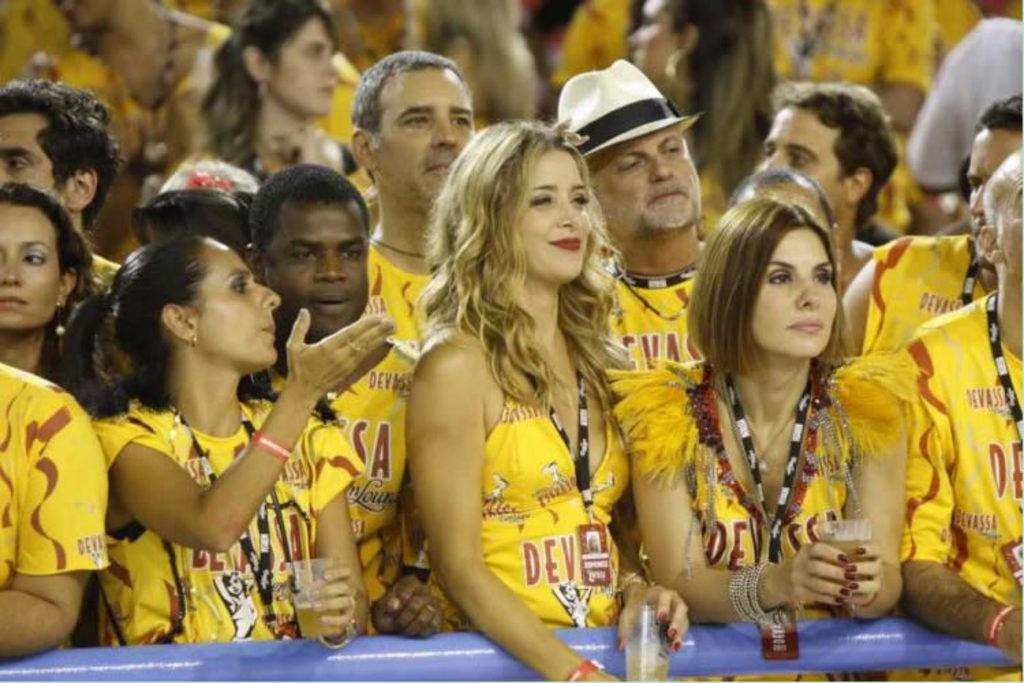How many people are in the image? The number of people in the image is not specified, but there are people present. What are some of the people holding in their hands? Some of the people are holding glasses in their hands. What type of pen is being used to write on the snow in the image? There is no pen or snow present in the image; it only shows people holding glasses. 